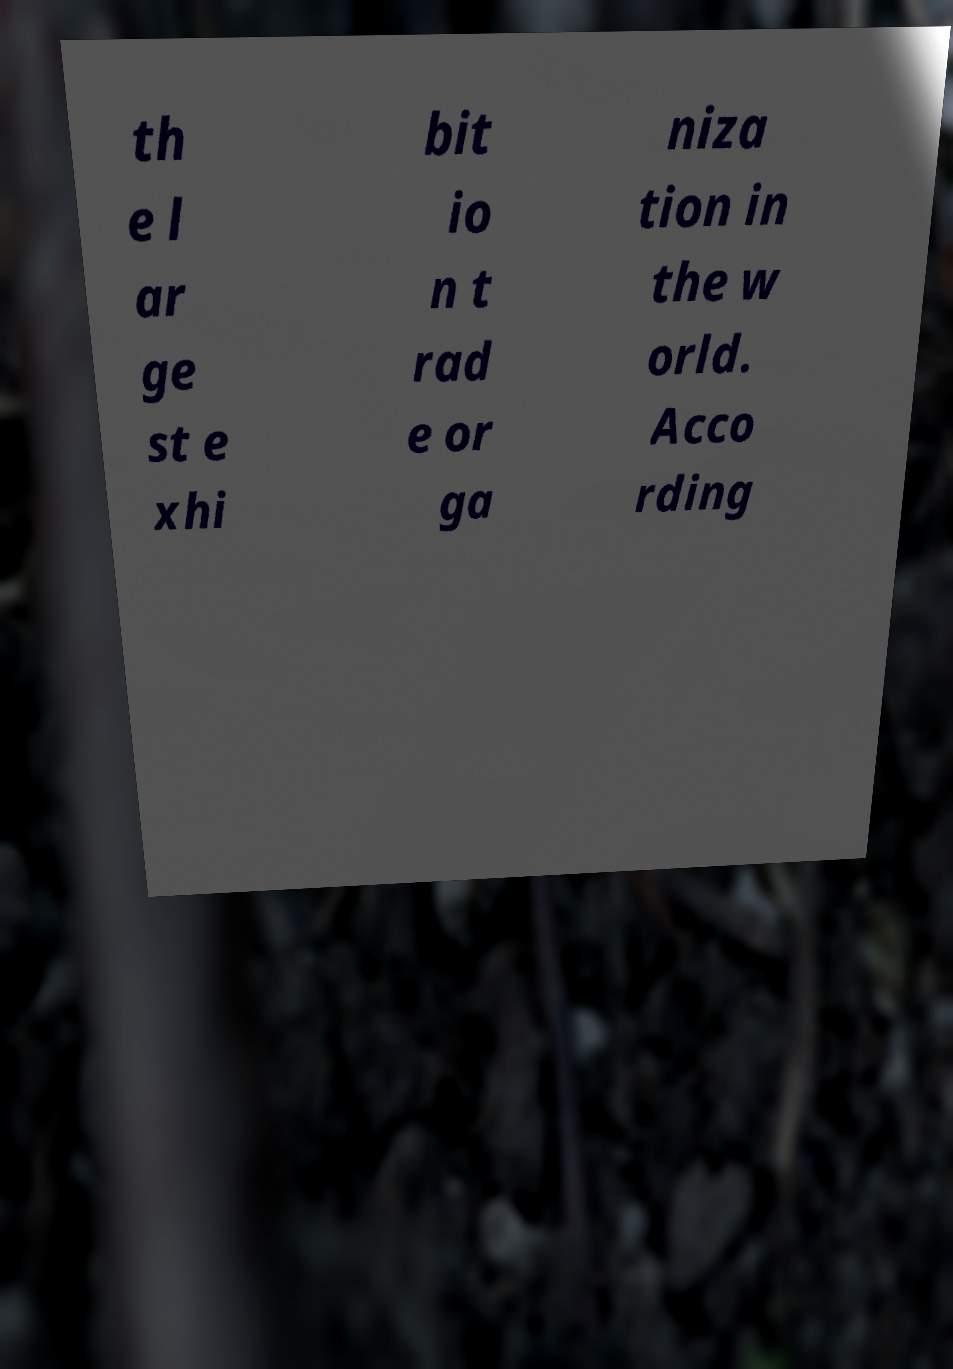I need the written content from this picture converted into text. Can you do that? th e l ar ge st e xhi bit io n t rad e or ga niza tion in the w orld. Acco rding 